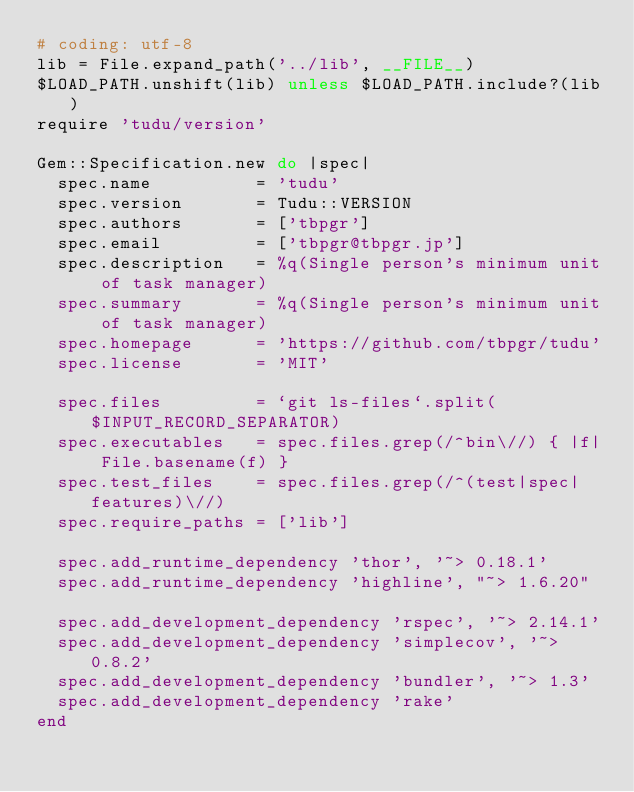Convert code to text. <code><loc_0><loc_0><loc_500><loc_500><_Ruby_># coding: utf-8
lib = File.expand_path('../lib', __FILE__)
$LOAD_PATH.unshift(lib) unless $LOAD_PATH.include?(lib)
require 'tudu/version'

Gem::Specification.new do |spec|
  spec.name          = 'tudu'
  spec.version       = Tudu::VERSION
  spec.authors       = ['tbpgr']
  spec.email         = ['tbpgr@tbpgr.jp']
  spec.description   = %q(Single person's minimum unit of task manager)
  spec.summary       = %q(Single person's minimum unit of task manager)
  spec.homepage      = 'https://github.com/tbpgr/tudu'
  spec.license       = 'MIT'

  spec.files         = `git ls-files`.split($INPUT_RECORD_SEPARATOR)
  spec.executables   = spec.files.grep(/^bin\//) { |f| File.basename(f) }
  spec.test_files    = spec.files.grep(/^(test|spec|features)\//)
  spec.require_paths = ['lib']

  spec.add_runtime_dependency 'thor', '~> 0.18.1'
  spec.add_runtime_dependency 'highline', "~> 1.6.20"

  spec.add_development_dependency 'rspec', '~> 2.14.1'
  spec.add_development_dependency 'simplecov', '~> 0.8.2'
  spec.add_development_dependency 'bundler', '~> 1.3'
  spec.add_development_dependency 'rake'
end
</code> 